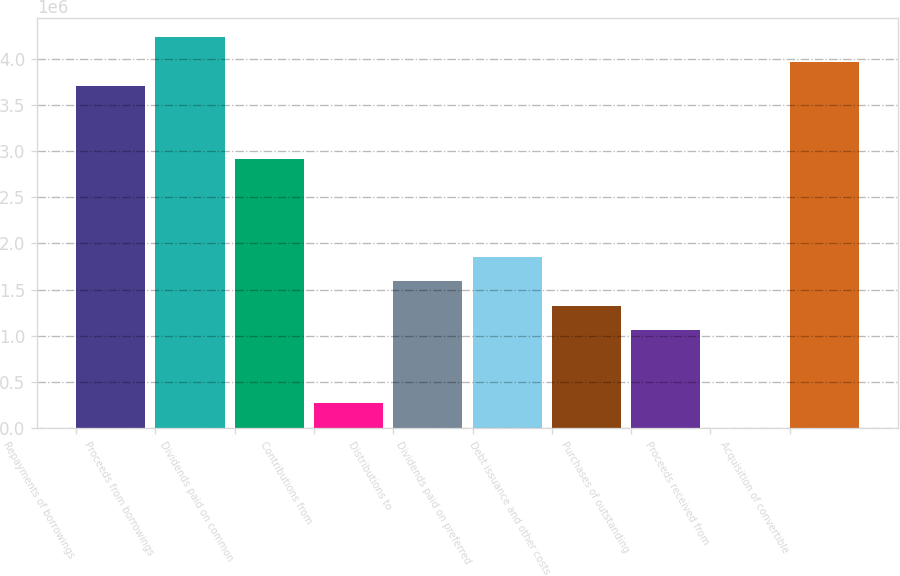Convert chart to OTSL. <chart><loc_0><loc_0><loc_500><loc_500><bar_chart><fcel>Repayments of borrowings<fcel>Proceeds from borrowings<fcel>Dividends paid on common<fcel>Contributions from<fcel>Distributions to<fcel>Dividends paid on preferred<fcel>Debt issuance and other costs<fcel>Purchases of outstanding<fcel>Proceeds received from<fcel>Acquisition of convertible<nl><fcel>3.70674e+06<fcel>4.23603e+06<fcel>2.91282e+06<fcel>266392<fcel>1.5896e+06<fcel>1.85425e+06<fcel>1.32496e+06<fcel>1.06032e+06<fcel>1750<fcel>3.97139e+06<nl></chart> 